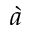Convert formula to latex. <formula><loc_0><loc_0><loc_500><loc_500>\grave { a }</formula> 